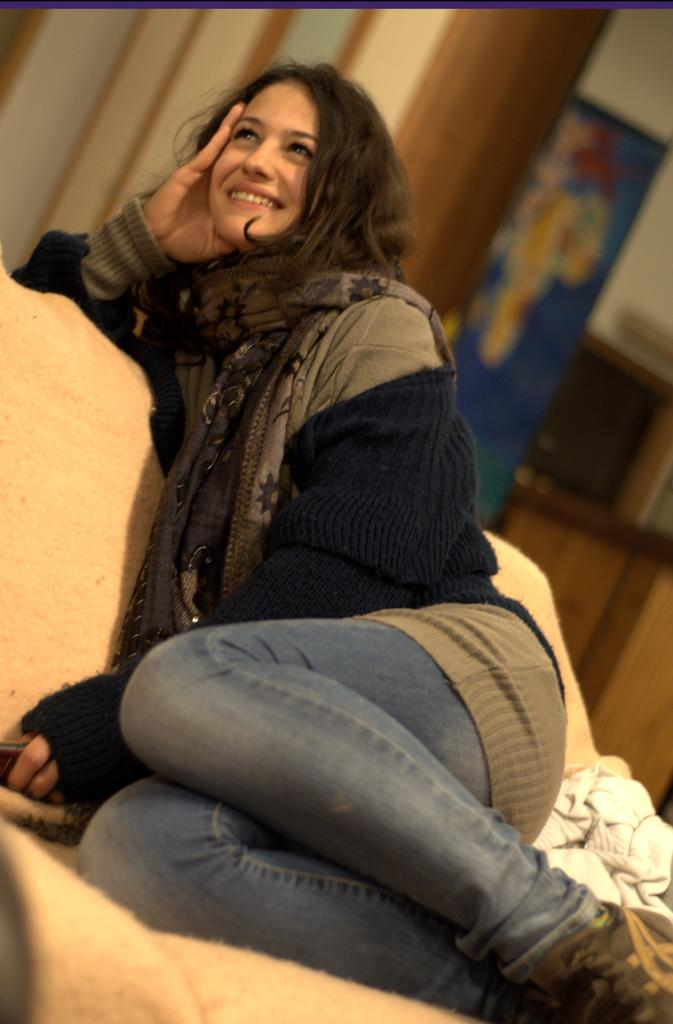What type of clothing is the woman wearing on her upper body in the image? The woman is wearing a jacket in the image. What accessory is the woman wearing around her neck? The woman is wearing a scarf in the image. What is the woman's facial expression in the image? The woman is smiling in the image. In which direction is the woman looking in the image? The woman is looking upwards in the image. How would you describe the background of the image? The background is blurred in the image. What can be seen in the distance in the image? There is a banner visible in the distance in the image. What color is the crayon the woman is holding in the image? There is no crayon present in the image; the woman is wearing a scarf and a jacket. What type of connection is the woman making with the machine in the image? There is no machine present in the image, and the woman is not making any connections. 